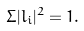Convert formula to latex. <formula><loc_0><loc_0><loc_500><loc_500>\Sigma | l _ { i } | ^ { 2 } = 1 .</formula> 